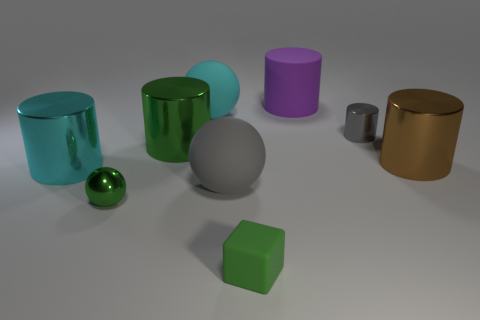Subtract all matte cylinders. How many cylinders are left? 4 Subtract all purple cylinders. How many cylinders are left? 4 Subtract 1 cylinders. How many cylinders are left? 4 Subtract all yellow cylinders. Subtract all red balls. How many cylinders are left? 5 Add 1 cyan metallic cylinders. How many objects exist? 10 Subtract all cylinders. How many objects are left? 4 Add 9 green cylinders. How many green cylinders are left? 10 Add 7 tiny brown objects. How many tiny brown objects exist? 7 Subtract 0 cyan blocks. How many objects are left? 9 Subtract all big cyan objects. Subtract all matte spheres. How many objects are left? 5 